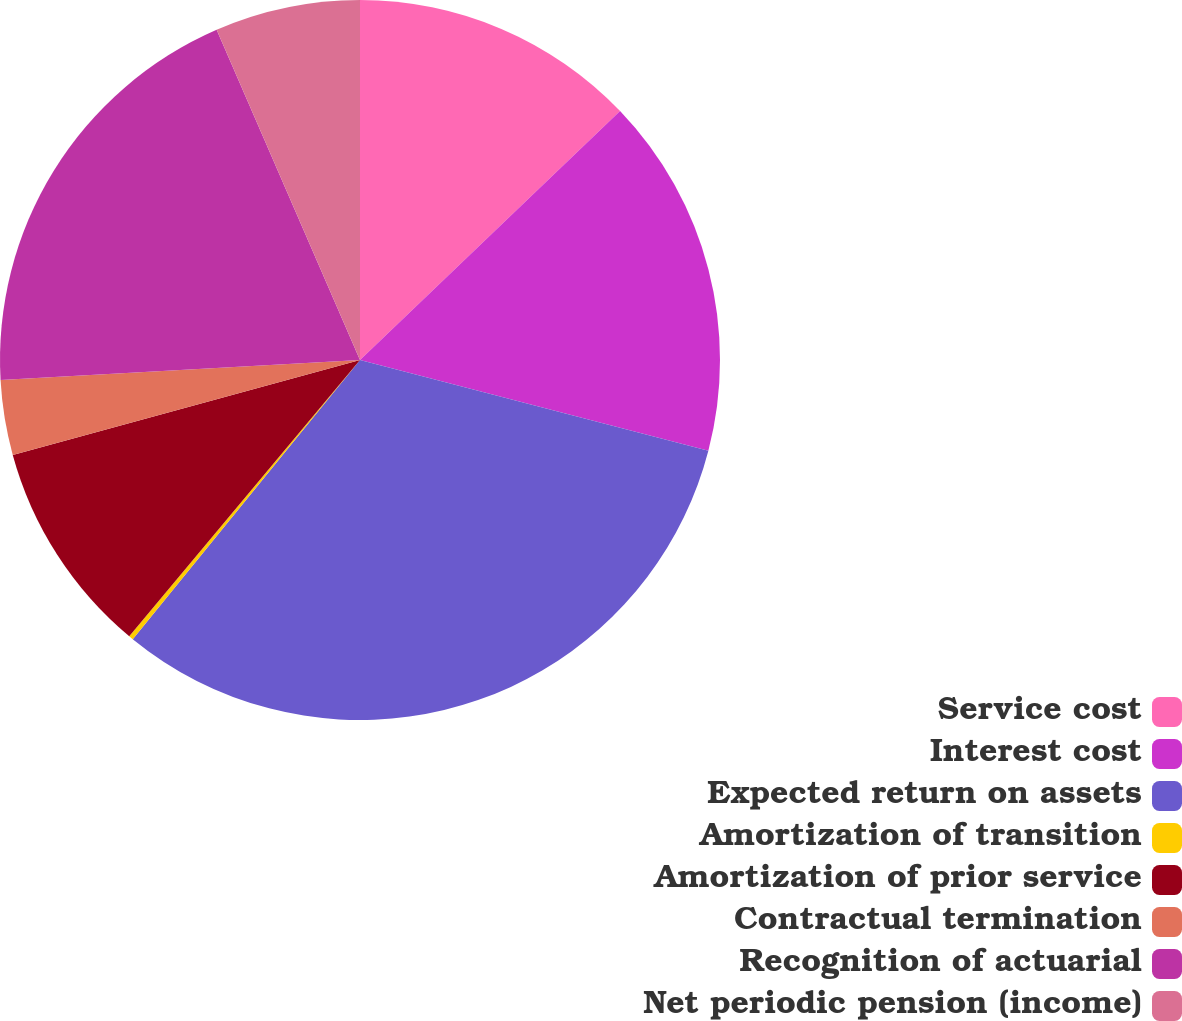Convert chart to OTSL. <chart><loc_0><loc_0><loc_500><loc_500><pie_chart><fcel>Service cost<fcel>Interest cost<fcel>Expected return on assets<fcel>Amortization of transition<fcel>Amortization of prior service<fcel>Contractual termination<fcel>Recognition of actuarial<fcel>Net periodic pension (income)<nl><fcel>12.85%<fcel>16.21%<fcel>31.82%<fcel>0.2%<fcel>9.68%<fcel>3.36%<fcel>19.37%<fcel>6.52%<nl></chart> 